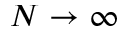<formula> <loc_0><loc_0><loc_500><loc_500>N \to \infty</formula> 